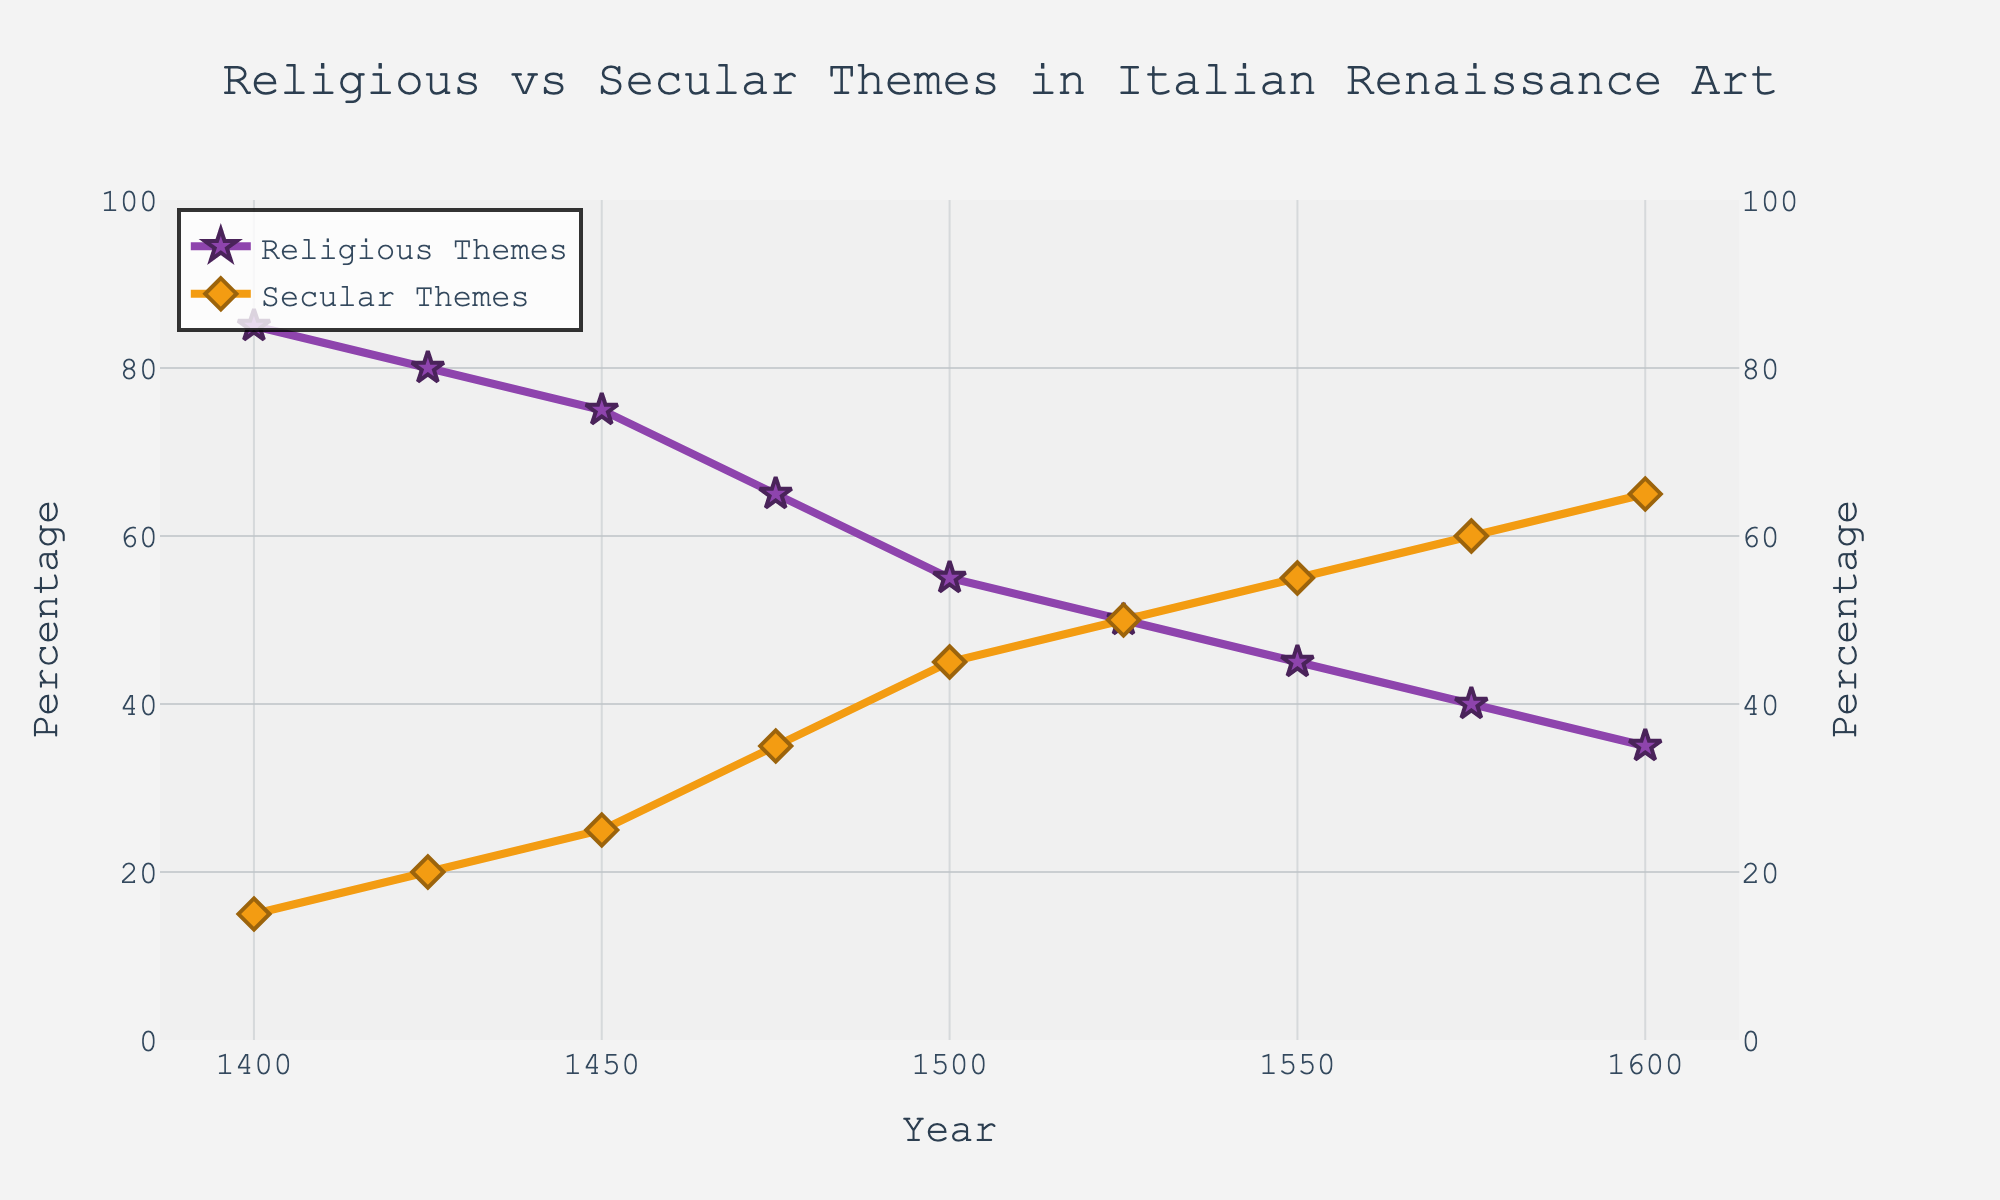What is the percentage of Religious Themes in the year 1400? Look at the line corresponding to Religious Themes, which is marked with stars. Find the point on the line at the year 1400. The y-axis value indicates the percentage.
Answer: 85% Has the percentage of Secular Themes increased or decreased over time? Observe the trend of the line corresponding to Secular Themes, which is marked with diamonds. From 1400 to 1600, the line is ascending, indicating an increase.
Answer: Increased In which year did Religious Themes and Secular Themes have the same percentage? Identify the point where the lines for Religious Themes (stars) and Secular Themes (diamonds) intersect. This occurs around the year 1525.
Answer: 1525 What is the difference in the percentage of Religious Themes between the years 1400 and 1600? Subtract the percentage of Religious Themes at 1600 from that at 1400. 85% (in 1400) - 35% (in 1600) = 50%.
Answer: 50% Which theme had a higher percentage in the year 1550? Compare the y-axis value for both lines at the year 1550. Secular Themes line (diamonds) is above the Religious Themes line (stars).
Answer: Secular Themes What was the average percentage of Religious Themes from 1400 to 1600? Add the percentages for Religious Themes across all given years and divide by the number of years (85 + 80 + 75 + 65 + 55 + 50 + 45 + 40 + 35) / 9 = 58.33%.
Answer: 58.33% Did the percentage of Religious Themes ever decrease sharply between consecutive years? If yes, between which years? Examine the trend of the Religious Themes line and identify any sudden drops. Between 1450 and 1475, there is a notable drop from 75% to 65%.
Answer: Yes, between 1450 and 1475 Between which two consecutive years did Secular Themes see the largest increase? Look for the steepest upward slope in the line for Secular Themes. The largest increase is from 1475 to 1500, where it jumps from 35% to 45%.
Answer: 1475 and 1500 At what percentage did the Religious Themes stabilize for some time, and during which years? Find where the line for Religious Themes appears horizontal. Between 1525 and 1550, it stays at 45%.
Answer: 45%, between 1525 and 1550 